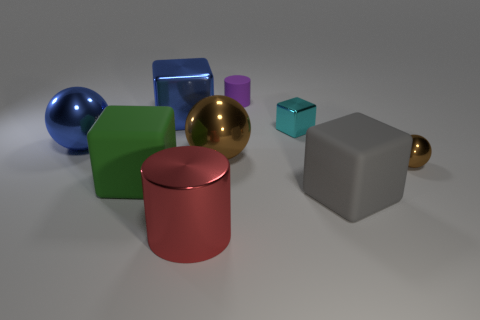What material is the large object that is the same color as the big shiny cube?
Provide a short and direct response. Metal. Is the big gray object the same shape as the purple rubber thing?
Your response must be concise. No. What number of other objects are the same material as the large gray block?
Offer a terse response. 2. What number of small brown things have the same shape as the big green rubber thing?
Give a very brief answer. 0. What color is the rubber object that is to the left of the large gray matte block and in front of the rubber cylinder?
Keep it short and to the point. Green. What number of big shiny balls are there?
Your answer should be compact. 2. Is the blue sphere the same size as the green cube?
Your answer should be compact. Yes. Are there any metallic balls of the same color as the small block?
Your response must be concise. No. Does the large red thing that is to the left of the purple cylinder have the same shape as the tiny brown object?
Your answer should be compact. No. How many purple cylinders are the same size as the gray object?
Offer a terse response. 0. 